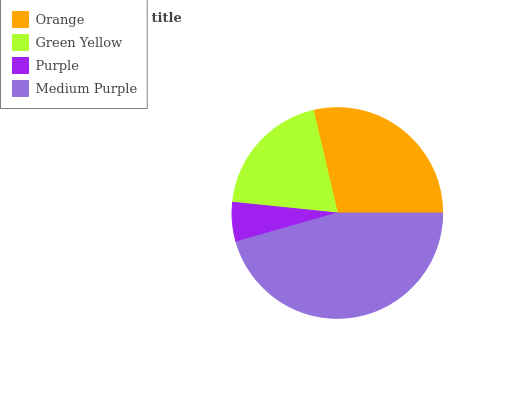Is Purple the minimum?
Answer yes or no. Yes. Is Medium Purple the maximum?
Answer yes or no. Yes. Is Green Yellow the minimum?
Answer yes or no. No. Is Green Yellow the maximum?
Answer yes or no. No. Is Orange greater than Green Yellow?
Answer yes or no. Yes. Is Green Yellow less than Orange?
Answer yes or no. Yes. Is Green Yellow greater than Orange?
Answer yes or no. No. Is Orange less than Green Yellow?
Answer yes or no. No. Is Orange the high median?
Answer yes or no. Yes. Is Green Yellow the low median?
Answer yes or no. Yes. Is Medium Purple the high median?
Answer yes or no. No. Is Medium Purple the low median?
Answer yes or no. No. 